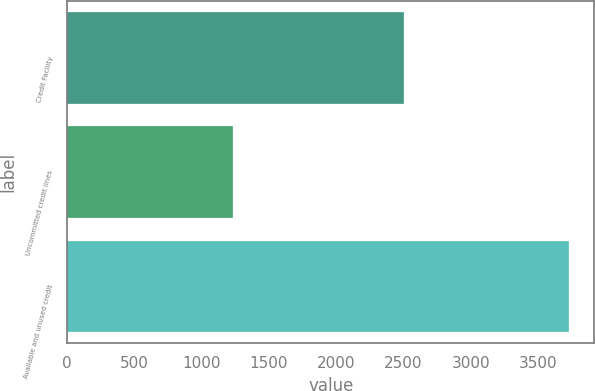<chart> <loc_0><loc_0><loc_500><loc_500><bar_chart><fcel>Credit Facility<fcel>Uncommitted credit lines<fcel>Available and unused credit<nl><fcel>2500<fcel>1231.6<fcel>3731.6<nl></chart> 